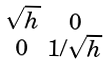<formula> <loc_0><loc_0><loc_500><loc_500>\begin{smallmatrix} \sqrt { h } & 0 \\ 0 & 1 / \sqrt { h } \end{smallmatrix}</formula> 